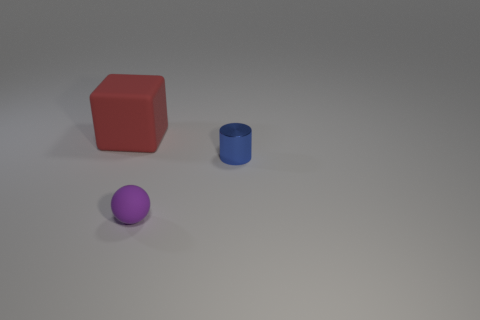Subtract all gray cylinders. How many brown spheres are left? 0 Subtract all cyan matte cylinders. Subtract all tiny balls. How many objects are left? 2 Add 3 balls. How many balls are left? 4 Add 2 red cubes. How many red cubes exist? 3 Add 1 blue balls. How many objects exist? 4 Subtract 0 red cylinders. How many objects are left? 3 Subtract all spheres. How many objects are left? 2 